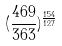<formula> <loc_0><loc_0><loc_500><loc_500>( \frac { 4 6 9 } { 3 6 3 } ) ^ { \frac { 1 5 4 } { 1 2 7 } }</formula> 